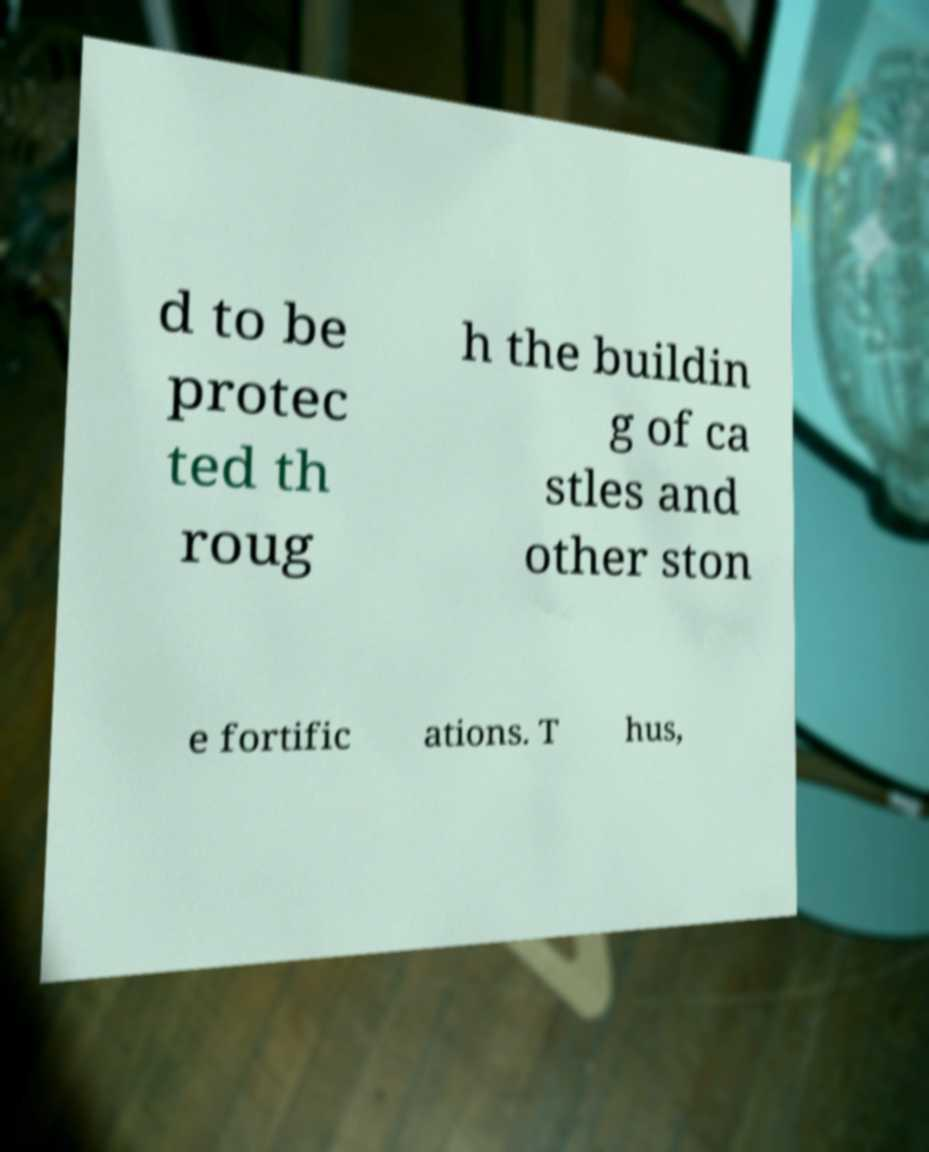What messages or text are displayed in this image? I need them in a readable, typed format. d to be protec ted th roug h the buildin g of ca stles and other ston e fortific ations. T hus, 